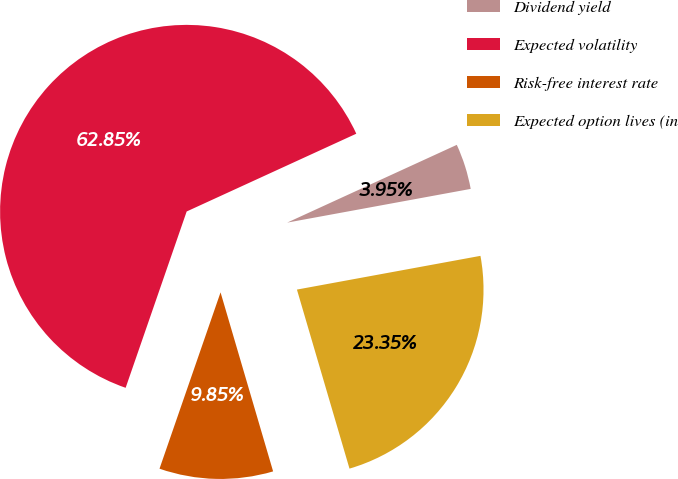Convert chart to OTSL. <chart><loc_0><loc_0><loc_500><loc_500><pie_chart><fcel>Dividend yield<fcel>Expected volatility<fcel>Risk-free interest rate<fcel>Expected option lives (in<nl><fcel>3.95%<fcel>62.86%<fcel>9.85%<fcel>23.35%<nl></chart> 